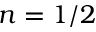<formula> <loc_0><loc_0><loc_500><loc_500>n = 1 / 2</formula> 